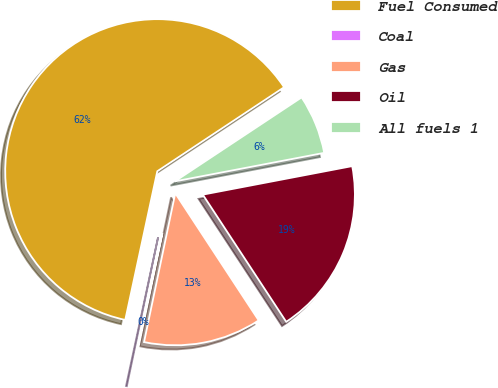Convert chart. <chart><loc_0><loc_0><loc_500><loc_500><pie_chart><fcel>Fuel Consumed<fcel>Coal<fcel>Gas<fcel>Oil<fcel>All fuels 1<nl><fcel>62.3%<fcel>0.09%<fcel>12.53%<fcel>18.76%<fcel>6.31%<nl></chart> 